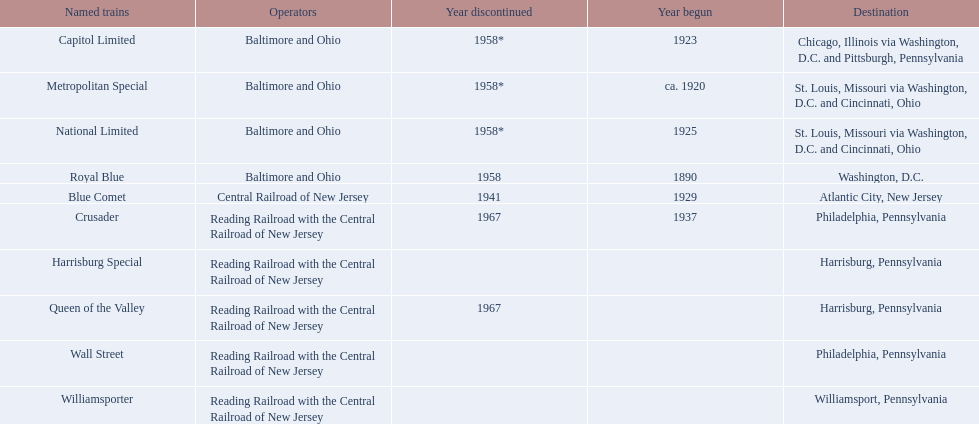What are the destinations of the central railroad of new jersey terminal? Chicago, Illinois via Washington, D.C. and Pittsburgh, Pennsylvania, St. Louis, Missouri via Washington, D.C. and Cincinnati, Ohio, St. Louis, Missouri via Washington, D.C. and Cincinnati, Ohio, Washington, D.C., Atlantic City, New Jersey, Philadelphia, Pennsylvania, Harrisburg, Pennsylvania, Harrisburg, Pennsylvania, Philadelphia, Pennsylvania, Williamsport, Pennsylvania. Which of these destinations is at the top of the list? Chicago, Illinois via Washington, D.C. and Pittsburgh, Pennsylvania. 